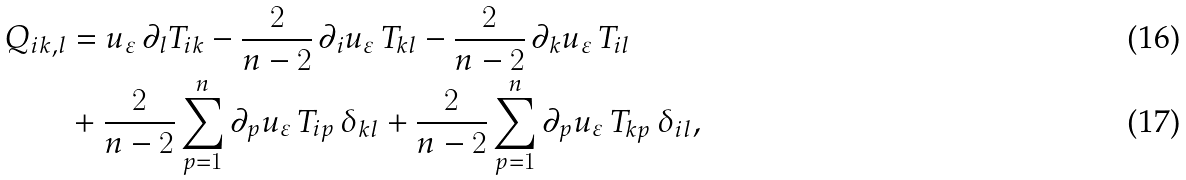<formula> <loc_0><loc_0><loc_500><loc_500>Q _ { i k , l } & = u _ { \varepsilon } \, \partial _ { l } T _ { i k } - \frac { 2 } { n - 2 } \, \partial _ { i } u _ { \varepsilon } \, T _ { k l } - \frac { 2 } { n - 2 } \, \partial _ { k } u _ { \varepsilon } \, T _ { i l } \\ & + \frac { 2 } { n - 2 } \sum _ { p = 1 } ^ { n } \partial _ { p } u _ { \varepsilon } \, T _ { i p } \, \delta _ { k l } + \frac { 2 } { n - 2 } \sum _ { p = 1 } ^ { n } \partial _ { p } u _ { \varepsilon } \, T _ { k p } \, \delta _ { i l } ,</formula> 